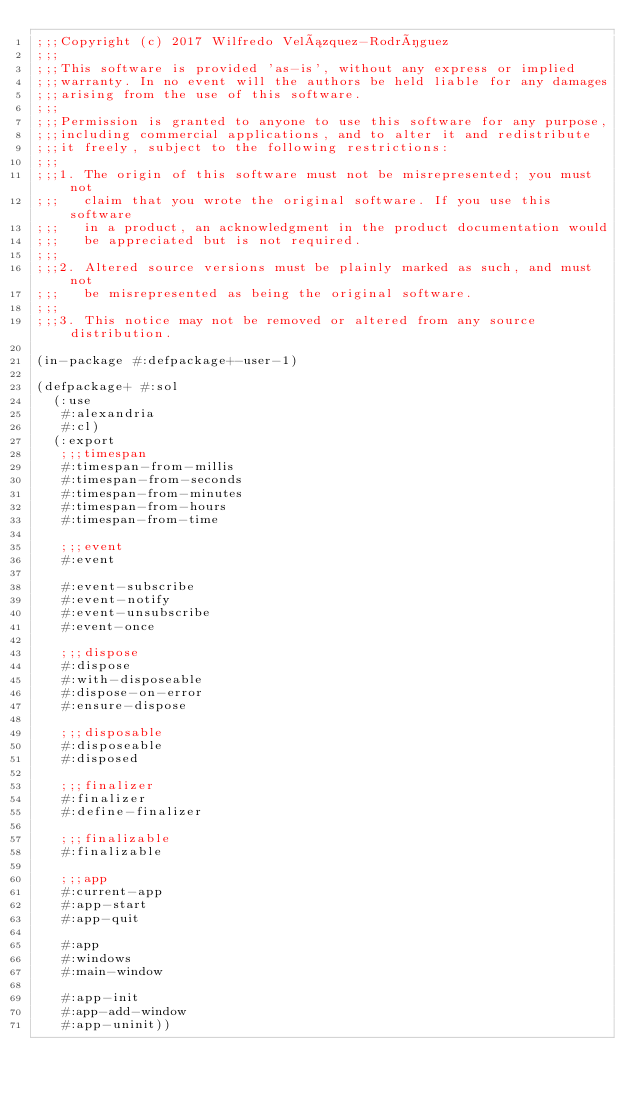Convert code to text. <code><loc_0><loc_0><loc_500><loc_500><_Lisp_>;;;Copyright (c) 2017 Wilfredo Velázquez-Rodríguez
;;;
;;;This software is provided 'as-is', without any express or implied
;;;warranty. In no event will the authors be held liable for any damages
;;;arising from the use of this software.
;;;
;;;Permission is granted to anyone to use this software for any purpose,
;;;including commercial applications, and to alter it and redistribute
;;;it freely, subject to the following restrictions:
;;;
;;;1. The origin of this software must not be misrepresented; you must not
;;;   claim that you wrote the original software. If you use this software
;;;   in a product, an acknowledgment in the product documentation would
;;;   be appreciated but is not required.
;;;
;;;2. Altered source versions must be plainly marked as such, and must not
;;;   be misrepresented as being the original software.
;;;
;;;3. This notice may not be removed or altered from any source distribution.

(in-package #:defpackage+-user-1)

(defpackage+ #:sol
  (:use
   #:alexandria
   #:cl)
  (:export
   ;;;timespan
   #:timespan-from-millis
   #:timespan-from-seconds
   #:timespan-from-minutes
   #:timespan-from-hours
   #:timespan-from-time

   ;;;event
   #:event

   #:event-subscribe
   #:event-notify
   #:event-unsubscribe
   #:event-once

   ;;;dispose
   #:dispose
   #:with-disposeable
   #:dispose-on-error
   #:ensure-dispose

   ;;;disposable
   #:disposeable
   #:disposed

   ;;;finalizer
   #:finalizer
   #:define-finalizer

   ;;;finalizable
   #:finalizable

   ;;;app
   #:current-app
   #:app-start
   #:app-quit

   #:app
   #:windows
   #:main-window

   #:app-init
   #:app-add-window
   #:app-uninit))
</code> 